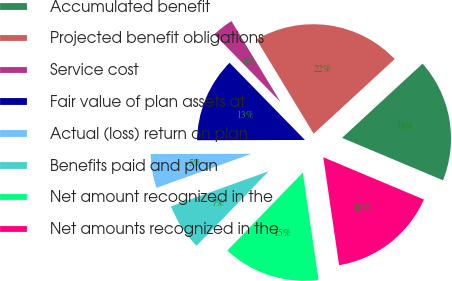Convert chart. <chart><loc_0><loc_0><loc_500><loc_500><pie_chart><fcel>Accumulated benefit<fcel>Projected benefit obligations<fcel>Service cost<fcel>Fair value of plan assets at<fcel>Actual (loss) return on plan<fcel>Benefits paid and plan<fcel>Net amount recognized in the<fcel>Net amounts recognized in the<nl><fcel>18.18%<fcel>21.82%<fcel>3.64%<fcel>12.73%<fcel>5.45%<fcel>7.27%<fcel>14.55%<fcel>16.36%<nl></chart> 